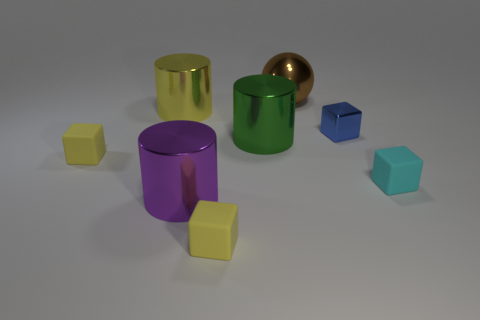Subtract all shiny cubes. How many cubes are left? 3 Subtract all blue blocks. How many blocks are left? 3 Subtract all yellow cylinders. How many yellow blocks are left? 2 Subtract all spheres. How many objects are left? 7 Add 1 big red things. How many objects exist? 9 Subtract 1 cylinders. How many cylinders are left? 2 Subtract 0 gray blocks. How many objects are left? 8 Subtract all yellow cylinders. Subtract all purple spheres. How many cylinders are left? 2 Subtract all tiny cubes. Subtract all large brown spheres. How many objects are left? 3 Add 2 yellow objects. How many yellow objects are left? 5 